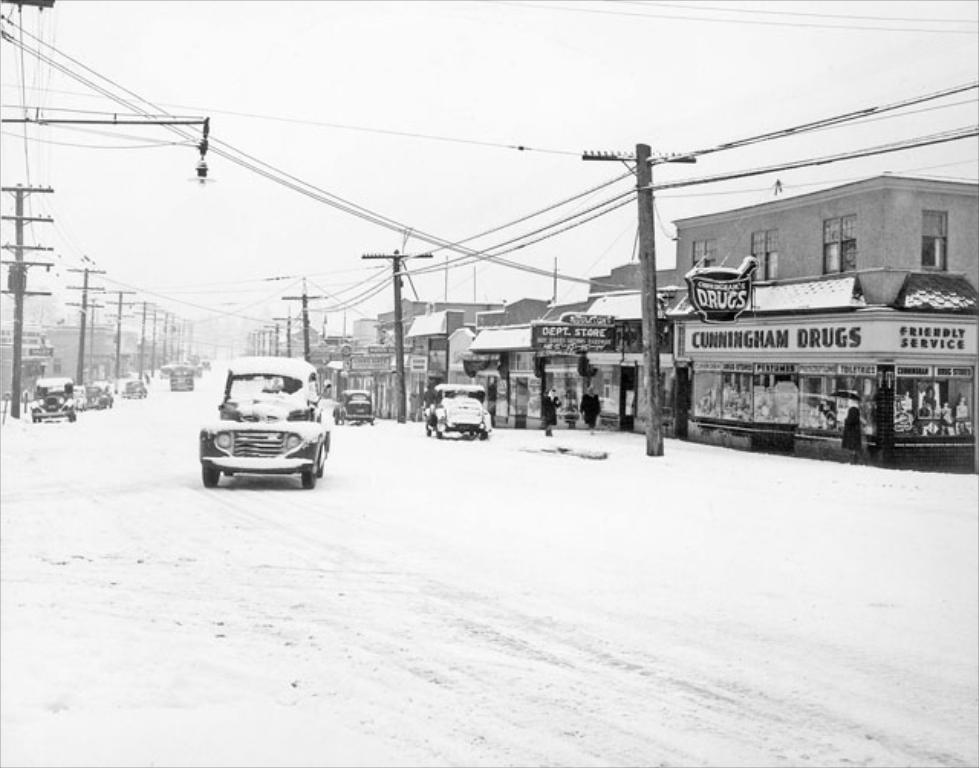What is the color scheme of the image? The image is black and white. What can be seen on the road in the image? There are vehicles on the road in the image. What structures are present in the image? There are poles and buildings in the image. What is visible in the background of the image? The sky is visible in the background of the image. What type of leather is used to make the rail in the image? There is no rail present in the image, and therefore no leather can be associated with it. 